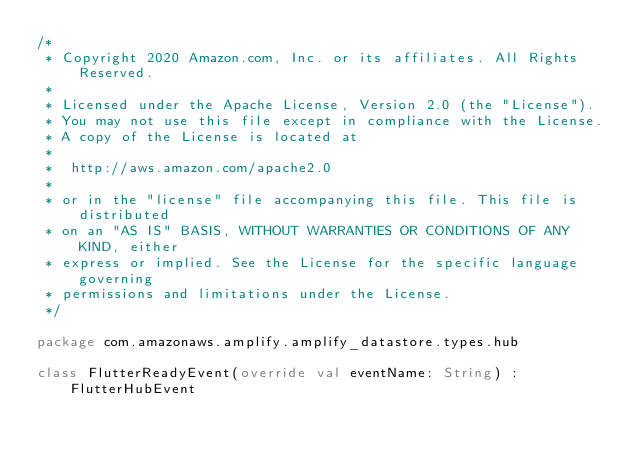<code> <loc_0><loc_0><loc_500><loc_500><_Kotlin_>/*
 * Copyright 2020 Amazon.com, Inc. or its affiliates. All Rights Reserved.
 *
 * Licensed under the Apache License, Version 2.0 (the "License").
 * You may not use this file except in compliance with the License.
 * A copy of the License is located at
 *
 *  http://aws.amazon.com/apache2.0
 *
 * or in the "license" file accompanying this file. This file is distributed
 * on an "AS IS" BASIS, WITHOUT WARRANTIES OR CONDITIONS OF ANY KIND, either
 * express or implied. See the License for the specific language governing
 * permissions and limitations under the License.
 */

package com.amazonaws.amplify.amplify_datastore.types.hub

class FlutterReadyEvent(override val eventName: String) : FlutterHubEvent
</code> 